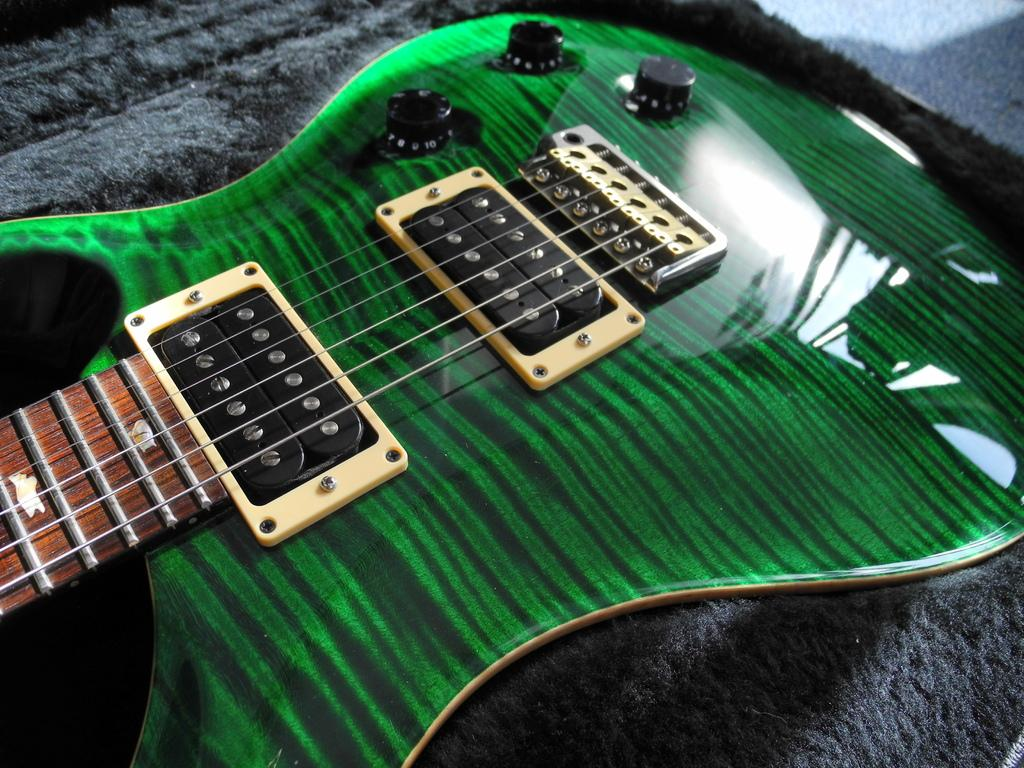What musical instrument is present in the image? There is a guitar in the image. What is the color of the guitar? The guitar is green in color. What feature of the guitar allows it to be played? The guitar has strings. On what surface is the guitar placed? The guitar is placed on a mat. How many apples are on the guitar strings in the image? There are no apples present on the guitar strings in the image. What type of stitch is used to repair the guitar in the image? There is no indication of any repair work on the guitar in the image, and therefore no stitch can be observed. 